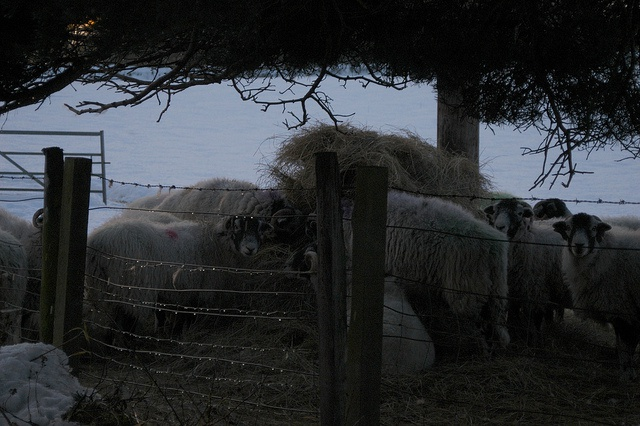Describe the objects in this image and their specific colors. I can see sheep in black, gray, and purple tones, sheep in black, gray, and purple tones, sheep in black and gray tones, sheep in black, gray, and purple tones, and sheep in black and purple tones in this image. 